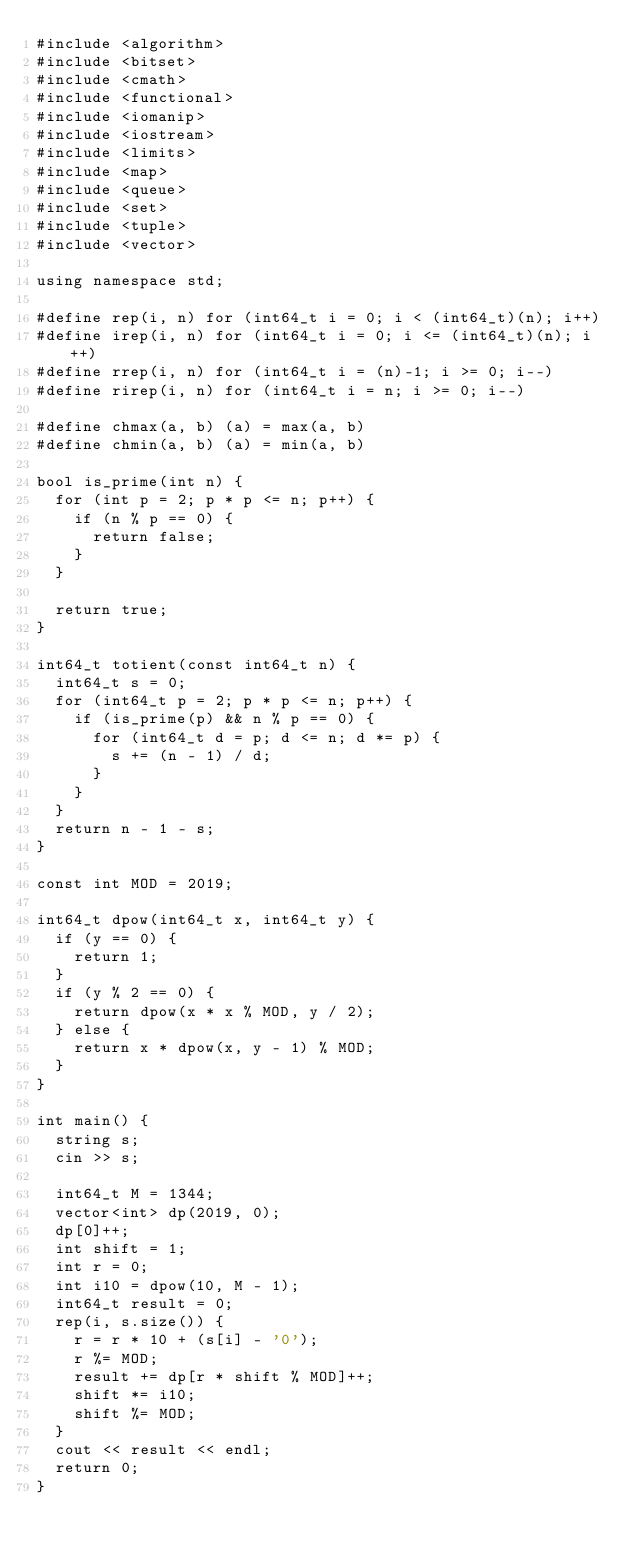<code> <loc_0><loc_0><loc_500><loc_500><_C++_>#include <algorithm>
#include <bitset>
#include <cmath>
#include <functional>
#include <iomanip>
#include <iostream>
#include <limits>
#include <map>
#include <queue>
#include <set>
#include <tuple>
#include <vector>

using namespace std;

#define rep(i, n) for (int64_t i = 0; i < (int64_t)(n); i++)
#define irep(i, n) for (int64_t i = 0; i <= (int64_t)(n); i++)
#define rrep(i, n) for (int64_t i = (n)-1; i >= 0; i--)
#define rirep(i, n) for (int64_t i = n; i >= 0; i--)

#define chmax(a, b) (a) = max(a, b)
#define chmin(a, b) (a) = min(a, b)

bool is_prime(int n) {
  for (int p = 2; p * p <= n; p++) {
    if (n % p == 0) {
      return false;
    }
  }

  return true;
}

int64_t totient(const int64_t n) {
  int64_t s = 0;
  for (int64_t p = 2; p * p <= n; p++) {
    if (is_prime(p) && n % p == 0) {
      for (int64_t d = p; d <= n; d *= p) {
        s += (n - 1) / d;
      }
    }
  }
  return n - 1 - s;
}

const int MOD = 2019;

int64_t dpow(int64_t x, int64_t y) {
  if (y == 0) {
    return 1;
  }
  if (y % 2 == 0) {
    return dpow(x * x % MOD, y / 2);
  } else {
    return x * dpow(x, y - 1) % MOD;
  }
}

int main() {
  string s;
  cin >> s;

  int64_t M = 1344;
  vector<int> dp(2019, 0);
  dp[0]++;
  int shift = 1;
  int r = 0;
  int i10 = dpow(10, M - 1);
  int64_t result = 0;
  rep(i, s.size()) {
    r = r * 10 + (s[i] - '0');
    r %= MOD;
    result += dp[r * shift % MOD]++;
    shift *= i10;
    shift %= MOD;
  }
  cout << result << endl;
  return 0;
}</code> 